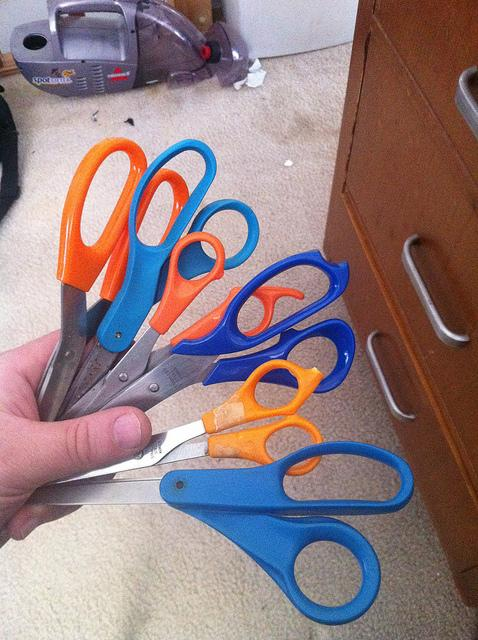What color is the smallest pair of scissors?

Choices:
A) pink
B) black
C) green
D) orange orange 